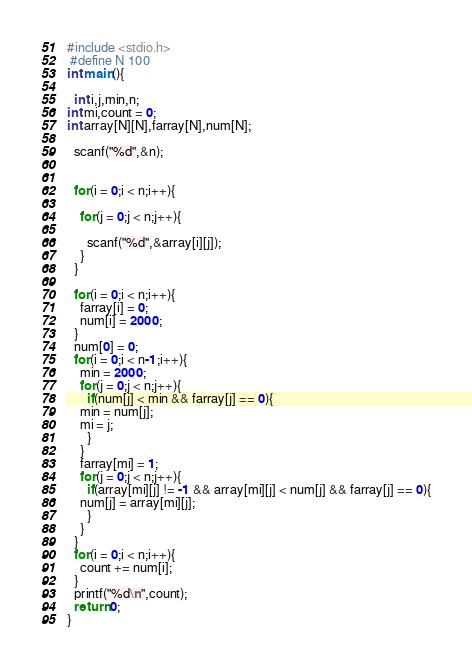Convert code to text. <code><loc_0><loc_0><loc_500><loc_500><_C_>#include <stdio.h>
 #define N 100
int main(){
   
  int i,j,min,n;
int mi,count = 0;
int array[N][N],farray[N],num[N];
 
  scanf("%d",&n);
   
   
  for(i = 0;i < n;i++){

    for(j = 0;j < n;j++){

      scanf("%d",&array[i][j]);
    }
  }

  for(i = 0;i < n;i++){
    farray[i] = 0;
    num[i] = 2000;
  }
  num[0] = 0; 
  for(i = 0;i < n-1;i++){
    min = 2000;
    for(j = 0;j < n;j++){
      if(num[j] < min && farray[j] == 0){
    min = num[j];
    mi = j;
      }
    }
    farray[mi] = 1;
    for(j = 0;j < n;j++){
      if(array[mi][j] != -1 && array[mi][j] < num[j] && farray[j] == 0){
    num[j] = array[mi][j];
      }
    }
  }
  for(i = 0;i < n;i++){
    count += num[i];
  }
  printf("%d\n",count);
  return 0;
}

</code> 